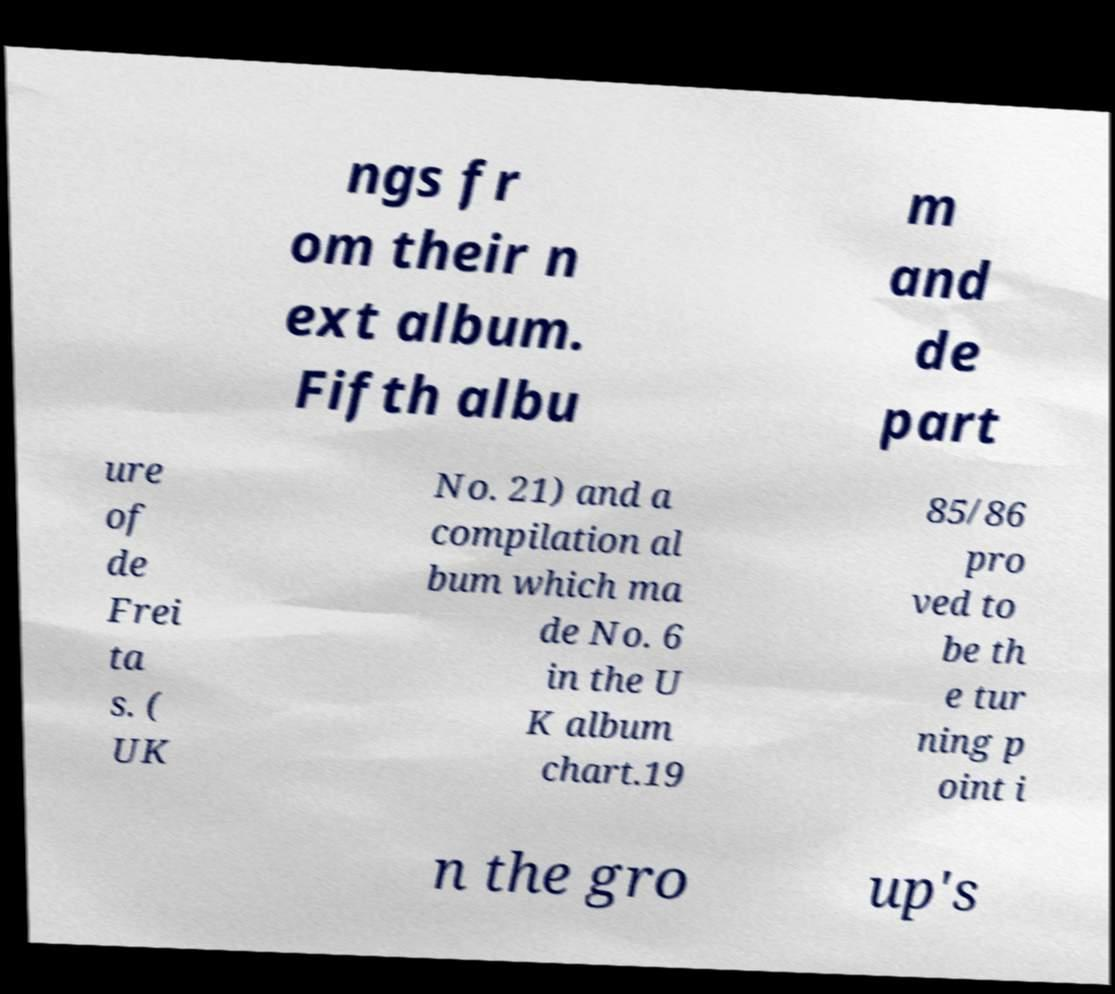For documentation purposes, I need the text within this image transcribed. Could you provide that? ngs fr om their n ext album. Fifth albu m and de part ure of de Frei ta s. ( UK No. 21) and a compilation al bum which ma de No. 6 in the U K album chart.19 85/86 pro ved to be th e tur ning p oint i n the gro up's 